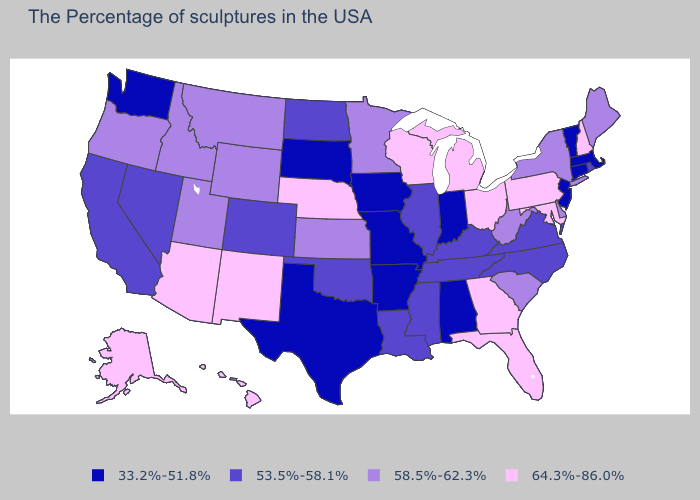Name the states that have a value in the range 58.5%-62.3%?
Answer briefly. Maine, New York, Delaware, South Carolina, West Virginia, Minnesota, Kansas, Wyoming, Utah, Montana, Idaho, Oregon. Which states have the lowest value in the USA?
Answer briefly. Massachusetts, Vermont, Connecticut, New Jersey, Indiana, Alabama, Missouri, Arkansas, Iowa, Texas, South Dakota, Washington. Which states have the highest value in the USA?
Quick response, please. New Hampshire, Maryland, Pennsylvania, Ohio, Florida, Georgia, Michigan, Wisconsin, Nebraska, New Mexico, Arizona, Alaska, Hawaii. Which states hav the highest value in the West?
Short answer required. New Mexico, Arizona, Alaska, Hawaii. Which states have the highest value in the USA?
Short answer required. New Hampshire, Maryland, Pennsylvania, Ohio, Florida, Georgia, Michigan, Wisconsin, Nebraska, New Mexico, Arizona, Alaska, Hawaii. Does the first symbol in the legend represent the smallest category?
Keep it brief. Yes. Name the states that have a value in the range 58.5%-62.3%?
Quick response, please. Maine, New York, Delaware, South Carolina, West Virginia, Minnesota, Kansas, Wyoming, Utah, Montana, Idaho, Oregon. What is the highest value in the South ?
Give a very brief answer. 64.3%-86.0%. Among the states that border Connecticut , which have the highest value?
Quick response, please. New York. Name the states that have a value in the range 58.5%-62.3%?
Write a very short answer. Maine, New York, Delaware, South Carolina, West Virginia, Minnesota, Kansas, Wyoming, Utah, Montana, Idaho, Oregon. Which states have the highest value in the USA?
Give a very brief answer. New Hampshire, Maryland, Pennsylvania, Ohio, Florida, Georgia, Michigan, Wisconsin, Nebraska, New Mexico, Arizona, Alaska, Hawaii. What is the value of Montana?
Short answer required. 58.5%-62.3%. Name the states that have a value in the range 53.5%-58.1%?
Give a very brief answer. Rhode Island, Virginia, North Carolina, Kentucky, Tennessee, Illinois, Mississippi, Louisiana, Oklahoma, North Dakota, Colorado, Nevada, California. What is the highest value in states that border Washington?
Short answer required. 58.5%-62.3%. 